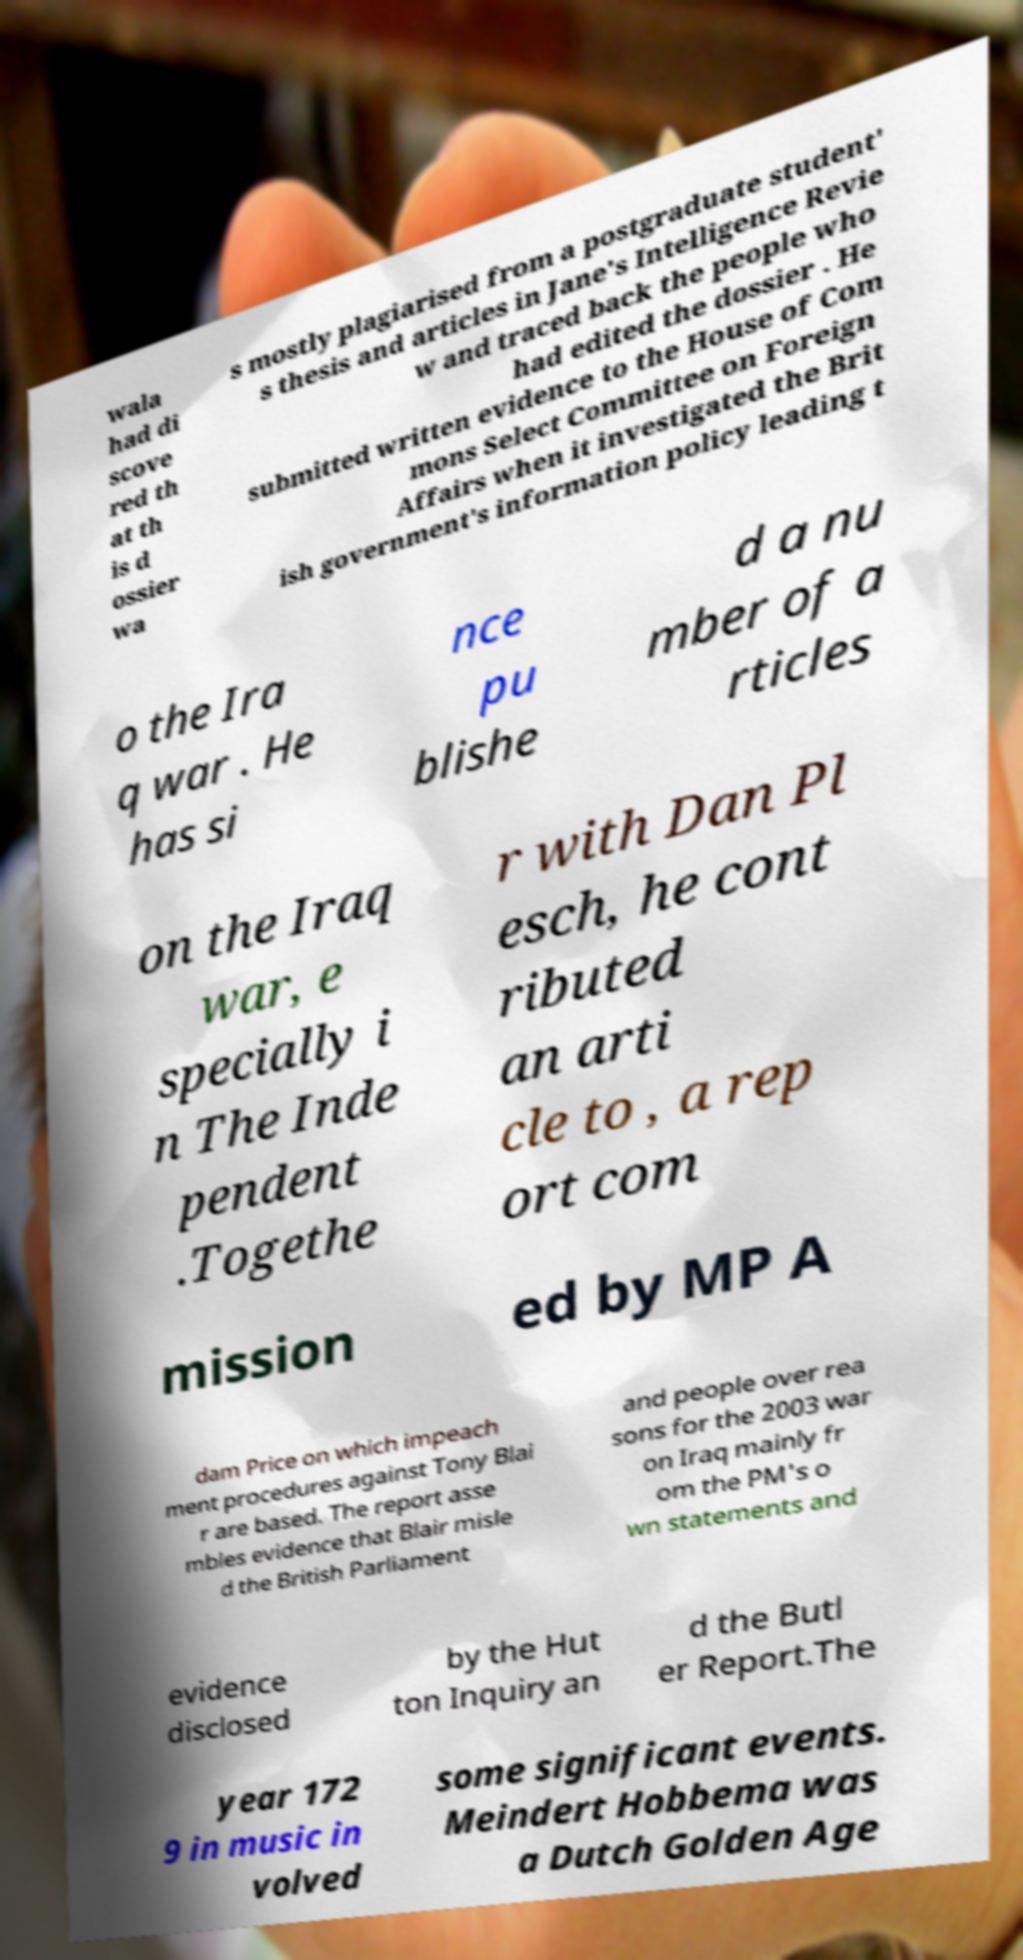Can you read and provide the text displayed in the image?This photo seems to have some interesting text. Can you extract and type it out for me? wala had di scove red th at th is d ossier wa s mostly plagiarised from a postgraduate student' s thesis and articles in Jane's Intelligence Revie w and traced back the people who had edited the dossier . He submitted written evidence to the House of Com mons Select Committee on Foreign Affairs when it investigated the Brit ish government's information policy leading t o the Ira q war . He has si nce pu blishe d a nu mber of a rticles on the Iraq war, e specially i n The Inde pendent .Togethe r with Dan Pl esch, he cont ributed an arti cle to , a rep ort com mission ed by MP A dam Price on which impeach ment procedures against Tony Blai r are based. The report asse mbles evidence that Blair misle d the British Parliament and people over rea sons for the 2003 war on Iraq mainly fr om the PM's o wn statements and evidence disclosed by the Hut ton Inquiry an d the Butl er Report.The year 172 9 in music in volved some significant events. Meindert Hobbema was a Dutch Golden Age 